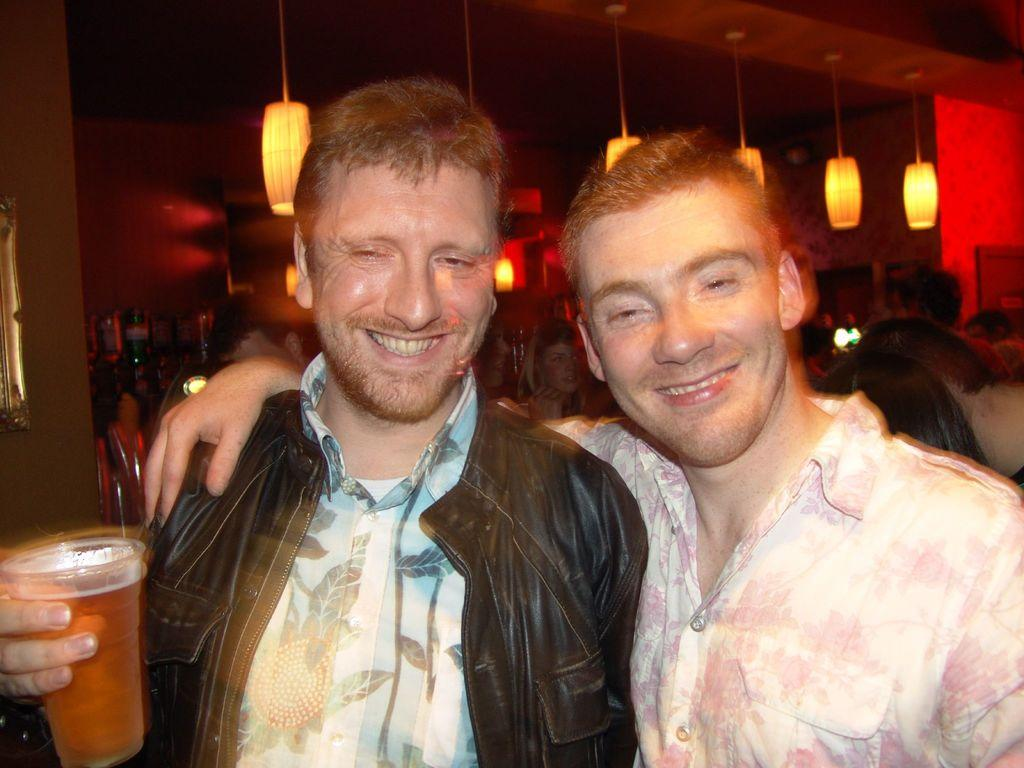How many people are visible in the image? There are two persons standing in the image. What are the expressions on their faces? Both persons are smiling. What is one person holding in the image? One person is holding a glass. Can you describe the background of the image? There are other people standing behind them, and the top of the image features a roof. What can be seen in the image that provides illumination? Lights are visible in the image. What type of bath can be seen in the image? There is no bath present in the image. Who is the dad of the person holding the glass in the image? The provided facts do not mention any familial relationships, so it is not possible to determine who the dad of the person holding the glass might be. 